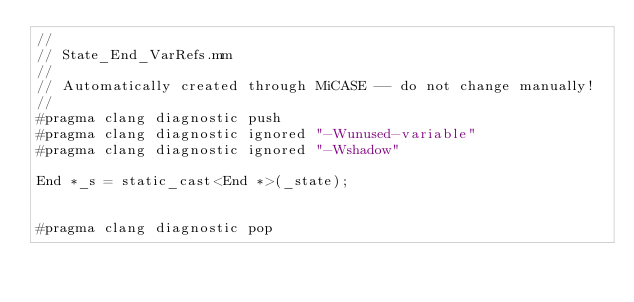<code> <loc_0><loc_0><loc_500><loc_500><_ObjectiveC_>//
// State_End_VarRefs.mm
//
// Automatically created through MiCASE -- do not change manually!
//
#pragma clang diagnostic push
#pragma clang diagnostic ignored "-Wunused-variable"
#pragma clang diagnostic ignored "-Wshadow"

End *_s = static_cast<End *>(_state);


#pragma clang diagnostic pop
</code> 